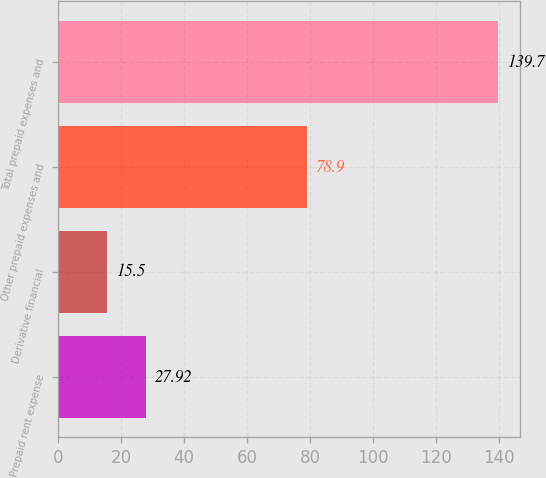<chart> <loc_0><loc_0><loc_500><loc_500><bar_chart><fcel>Prepaid rent expense<fcel>Derivative financial<fcel>Other prepaid expenses and<fcel>Total prepaid expenses and<nl><fcel>27.92<fcel>15.5<fcel>78.9<fcel>139.7<nl></chart> 